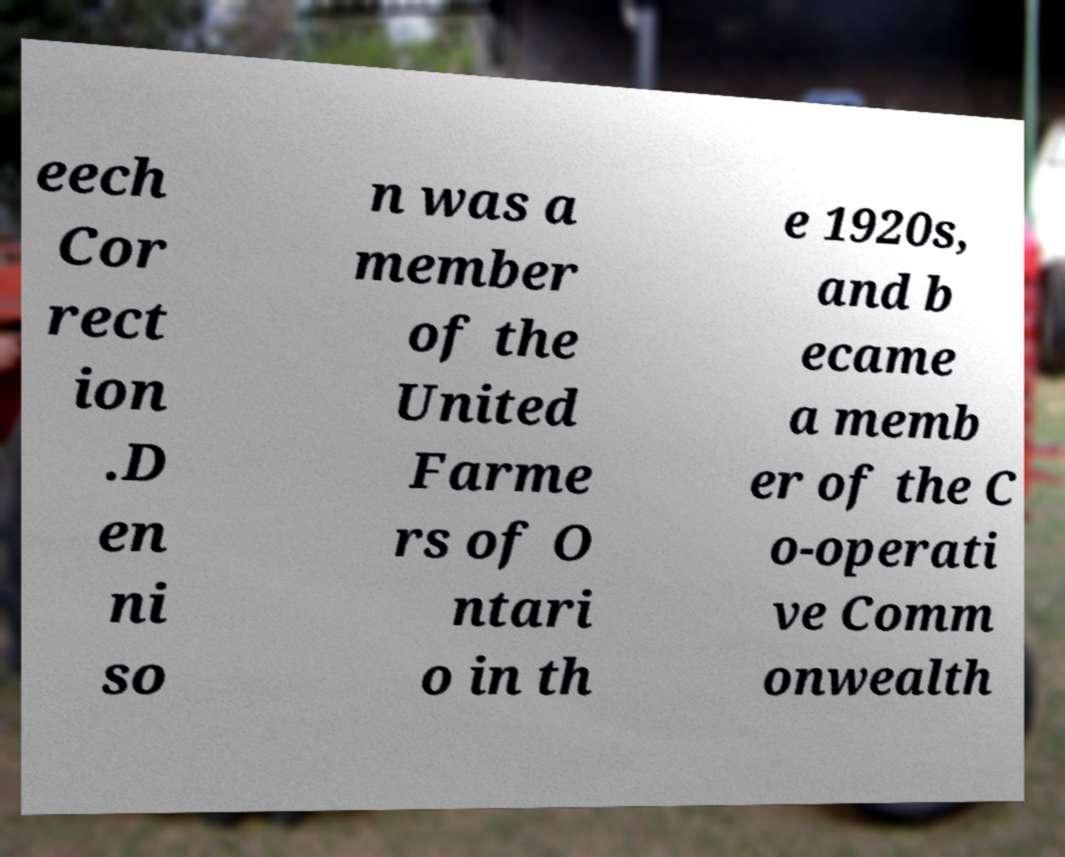I need the written content from this picture converted into text. Can you do that? eech Cor rect ion .D en ni so n was a member of the United Farme rs of O ntari o in th e 1920s, and b ecame a memb er of the C o-operati ve Comm onwealth 